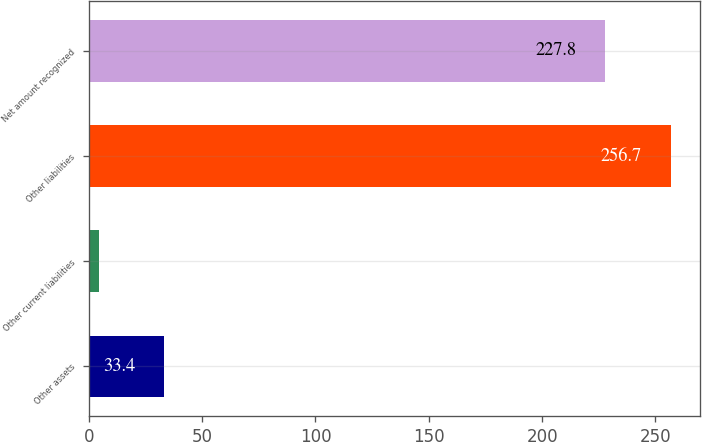Convert chart. <chart><loc_0><loc_0><loc_500><loc_500><bar_chart><fcel>Other assets<fcel>Other current liabilities<fcel>Other liabilities<fcel>Net amount recognized<nl><fcel>33.4<fcel>4.5<fcel>256.7<fcel>227.8<nl></chart> 